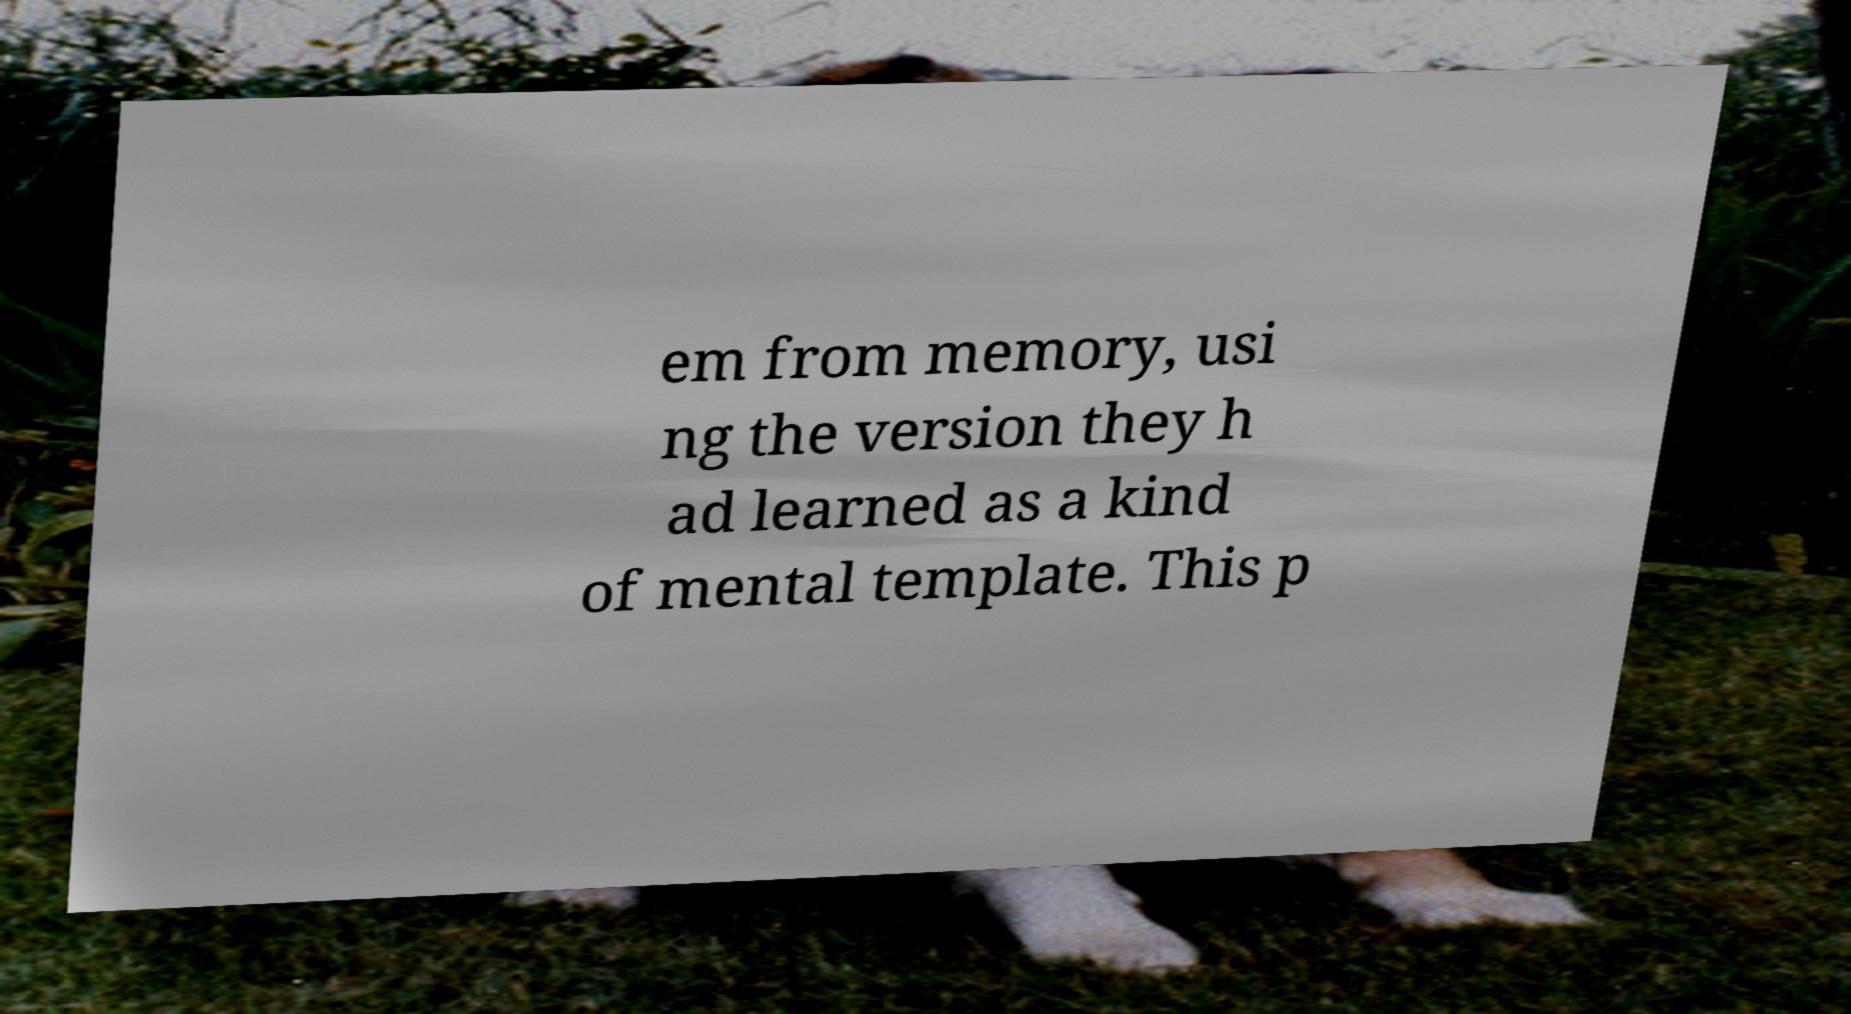There's text embedded in this image that I need extracted. Can you transcribe it verbatim? em from memory, usi ng the version they h ad learned as a kind of mental template. This p 